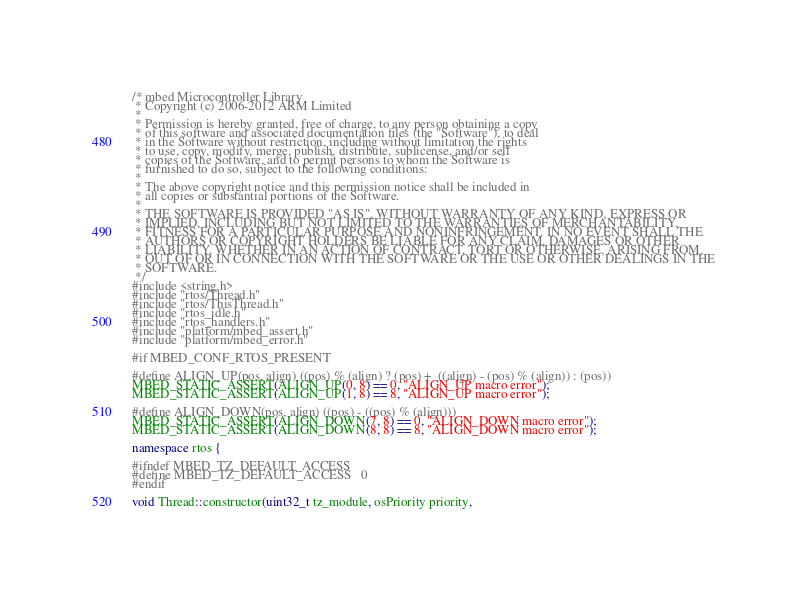Convert code to text. <code><loc_0><loc_0><loc_500><loc_500><_C++_>/* mbed Microcontroller Library
 * Copyright (c) 2006-2012 ARM Limited
 *
 * Permission is hereby granted, free of charge, to any person obtaining a copy
 * of this software and associated documentation files (the "Software"), to deal
 * in the Software without restriction, including without limitation the rights
 * to use, copy, modify, merge, publish, distribute, sublicense, and/or sell
 * copies of the Software, and to permit persons to whom the Software is
 * furnished to do so, subject to the following conditions:
 *
 * The above copyright notice and this permission notice shall be included in
 * all copies or substantial portions of the Software.
 *
 * THE SOFTWARE IS PROVIDED "AS IS", WITHOUT WARRANTY OF ANY KIND, EXPRESS OR
 * IMPLIED, INCLUDING BUT NOT LIMITED TO THE WARRANTIES OF MERCHANTABILITY,
 * FITNESS FOR A PARTICULAR PURPOSE AND NONINFRINGEMENT. IN NO EVENT SHALL THE
 * AUTHORS OR COPYRIGHT HOLDERS BE LIABLE FOR ANY CLAIM, DAMAGES OR OTHER
 * LIABILITY, WHETHER IN AN ACTION OF CONTRACT, TORT OR OTHERWISE, ARISING FROM,
 * OUT OF OR IN CONNECTION WITH THE SOFTWARE OR THE USE OR OTHER DEALINGS IN THE
 * SOFTWARE.
 */
#include <string.h>
#include "rtos/Thread.h"
#include "rtos/ThisThread.h"
#include "rtos_idle.h"
#include "rtos_handlers.h"
#include "platform/mbed_assert.h"
#include "platform/mbed_error.h"

#if MBED_CONF_RTOS_PRESENT

#define ALIGN_UP(pos, align) ((pos) % (align) ? (pos) +  ((align) - (pos) % (align)) : (pos))
MBED_STATIC_ASSERT(ALIGN_UP(0, 8) == 0, "ALIGN_UP macro error");
MBED_STATIC_ASSERT(ALIGN_UP(1, 8) == 8, "ALIGN_UP macro error");

#define ALIGN_DOWN(pos, align) ((pos) - ((pos) % (align)))
MBED_STATIC_ASSERT(ALIGN_DOWN(7, 8) == 0, "ALIGN_DOWN macro error");
MBED_STATIC_ASSERT(ALIGN_DOWN(8, 8) == 8, "ALIGN_DOWN macro error");

namespace rtos {

#ifndef MBED_TZ_DEFAULT_ACCESS
#define MBED_TZ_DEFAULT_ACCESS   0
#endif

void Thread::constructor(uint32_t tz_module, osPriority priority,</code> 